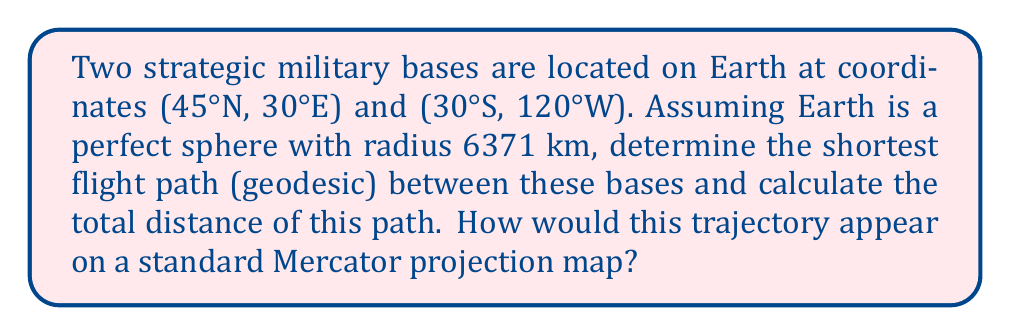Provide a solution to this math problem. To solve this problem, we'll use spherical geometry and the concepts of great circles on a spherical manifold.

1) First, we need to convert the given coordinates to radians:
   Base A: (45°N, 30°E) = ($\frac{\pi}{4}$, $\frac{\pi}{6}$)
   Base B: (30°S, 120°W) = ($-\frac{\pi}{6}$, $-\frac{2\pi}{3}$)

2) The shortest path between two points on a sphere is always along a great circle. We can find the central angle $\theta$ between the two points using the spherical law of cosines:

   $$\cos(\theta) = \sin(\phi_1)\sin(\phi_2) + \cos(\phi_1)\cos(\phi_2)\cos(\Delta\lambda)$$

   Where $\phi_1$ and $\phi_2$ are the latitudes, and $\Delta\lambda$ is the difference in longitudes.

3) Plugging in our values:

   $$\cos(\theta) = \sin(\frac{\pi}{4})\sin(-\frac{\pi}{6}) + \cos(\frac{\pi}{4})\cos(-\frac{\pi}{6})\cos(\frac{\pi}{6} - (-\frac{2\pi}{3}))$$

4) Simplifying:

   $$\cos(\theta) = \frac{\sqrt{2}}{2} \cdot (-\frac{1}{2}) + \frac{\sqrt{2}}{2} \cdot \frac{\sqrt{3}}{2} \cdot \cos(\frac{5\pi}{6})$$

5) Calculating:

   $$\cos(\theta) \approx -0.0825$$

6) Taking the inverse cosine:

   $$\theta \approx 1.6537 \text{ radians}$$

7) To find the distance, we multiply by Earth's radius:

   $$d = R\theta = 6371 \text{ km} \cdot 1.6537 \approx 10,535 \text{ km}$$

8) On a Mercator projection, this geodesic would appear as a curved line, bowing towards the north. This is because Mercator projections distort distances and shapes, especially near the poles. The actual shortest path would cross higher latitudes than a straight line on the Mercator projection would suggest.

[asy]
import geometry;

size(200,100);

path p = (0,0)--(200,0);
draw(p);
draw((0,50)--(200,50),dashed);
draw((0,100)--(200,100));

label("Equator", (100,0), S);
label("North Pole", (100,100), N);

dot((40,75));
dot((160,-25));

draw((40,75)..(100,85)..(160,-25), blue);
draw((40,75)--(160,-25), red+dashed);

label("A", (40,75), NW);
label("B", (160,-25), SE);
label("Geodesic", (100,60), NE, blue);
label("Mercator straight line", (100,25), SE, red);
[/asy]
Answer: The geodesic distance between the two military bases is approximately 10,535 km. On a Mercator projection map, this path would appear as a curved line bowing northward, rather than a straight line between the two points. 